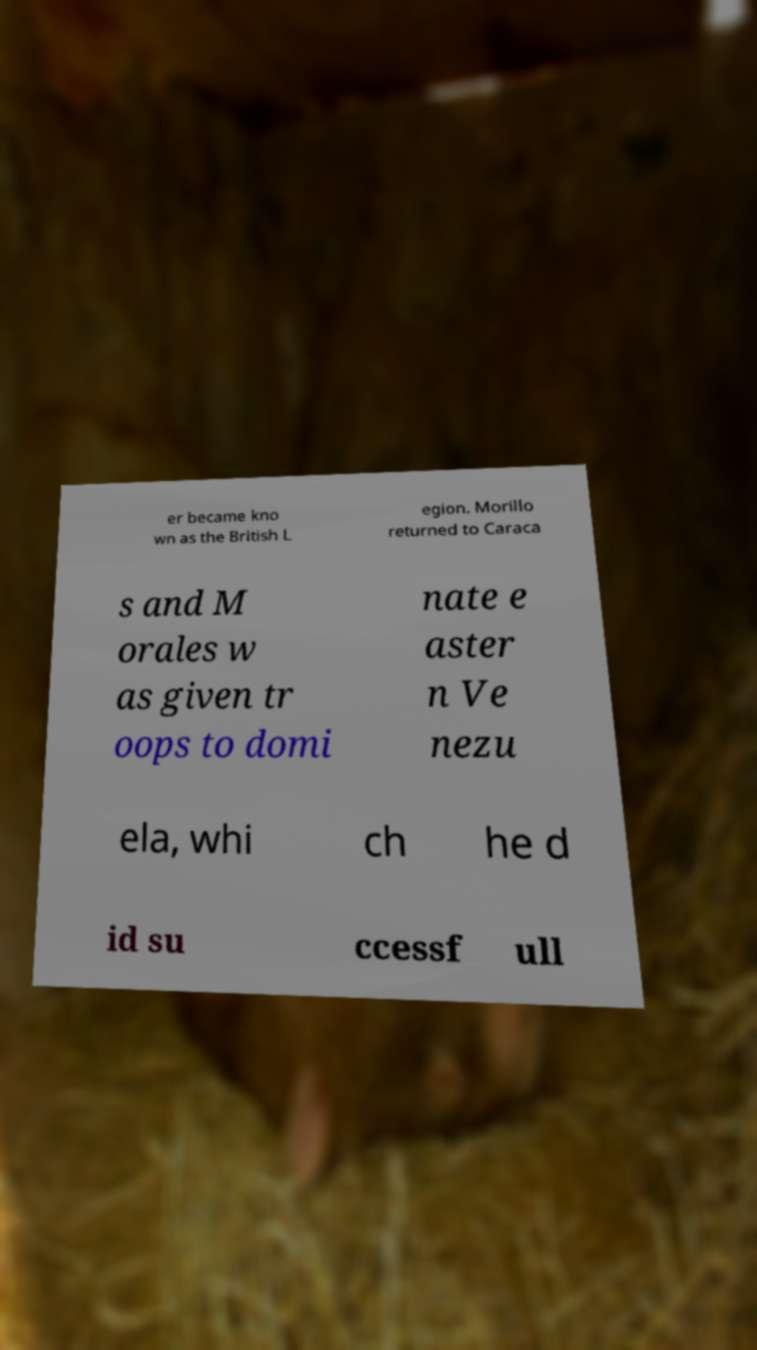For documentation purposes, I need the text within this image transcribed. Could you provide that? er became kno wn as the British L egion. Morillo returned to Caraca s and M orales w as given tr oops to domi nate e aster n Ve nezu ela, whi ch he d id su ccessf ull 